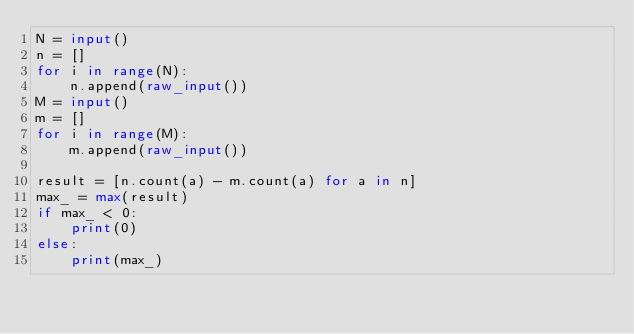<code> <loc_0><loc_0><loc_500><loc_500><_Python_>N = input()
n = []
for i in range(N):
    n.append(raw_input())
M = input()
m = []
for i in range(M):
    m.append(raw_input())

result = [n.count(a) - m.count(a) for a in n]
max_ = max(result)
if max_ < 0:
    print(0)
else:
    print(max_)</code> 